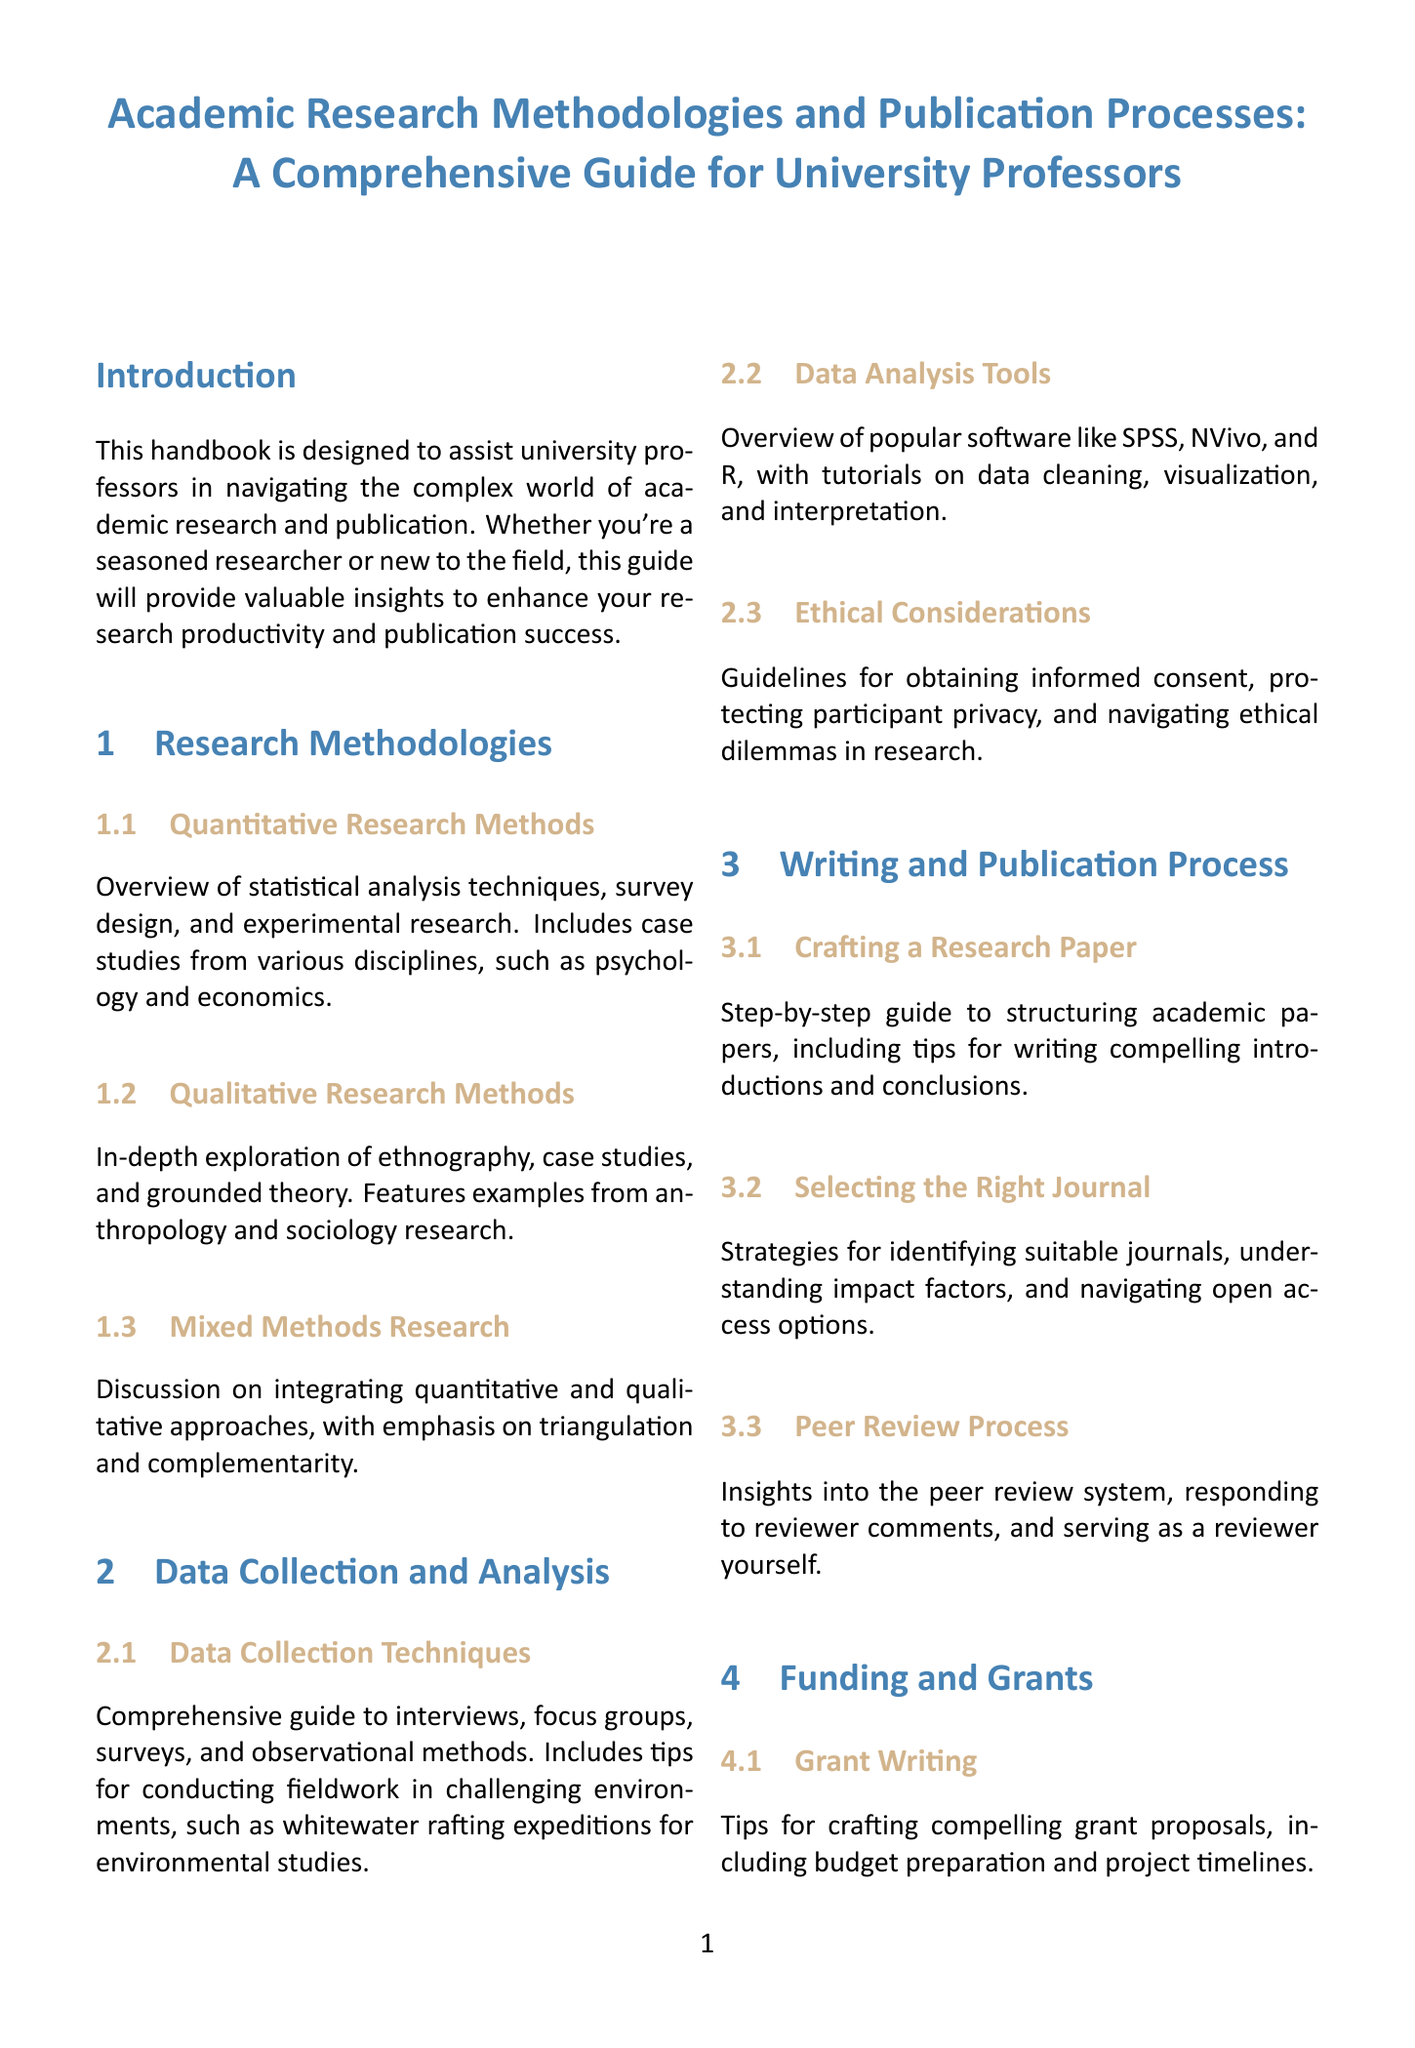What is the title of the handbook? The title is provided at the beginning of the document, clearly stating the focus of the content.
Answer: Academic Research Methodologies and Publication Processes: A Comprehensive Guide for University Professors How many main sections are in the document? The document structure includes multiple major sections for clarity, which can be counted for this information.
Answer: 9 What method is discussed in the section on qualitative research? The subsection specifically mentions the types of qualitative approaches covered in that section.
Answer: Ethnography Which software is mentioned for data analysis? The document lists several software tools available for data analysis and their applications.
Answer: SPSS What is included in Appendix B? The appendix provides specific tools and information relevant to a common academic process for professors.
Answer: Journal Submission Checklist What strategy is suggested for building research teams? The section outlines approaches to create effective collaborative working groups for research.
Answer: Assembling interdisciplinary teams What trend is discussed in the Emerging Trends section? This section addresses significant movements influencing current academic research practices.
Answer: Open Science Movement What does mixed methods research emphasize? The subsection highlights the core principles that guide the integration of both research approaches.
Answer: Triangulation and complementarity What is the focus of the case studies section? This section provides practical examples to illustrate the application of theories discussed in the handbook.
Answer: Successful research projects and publication journeys 